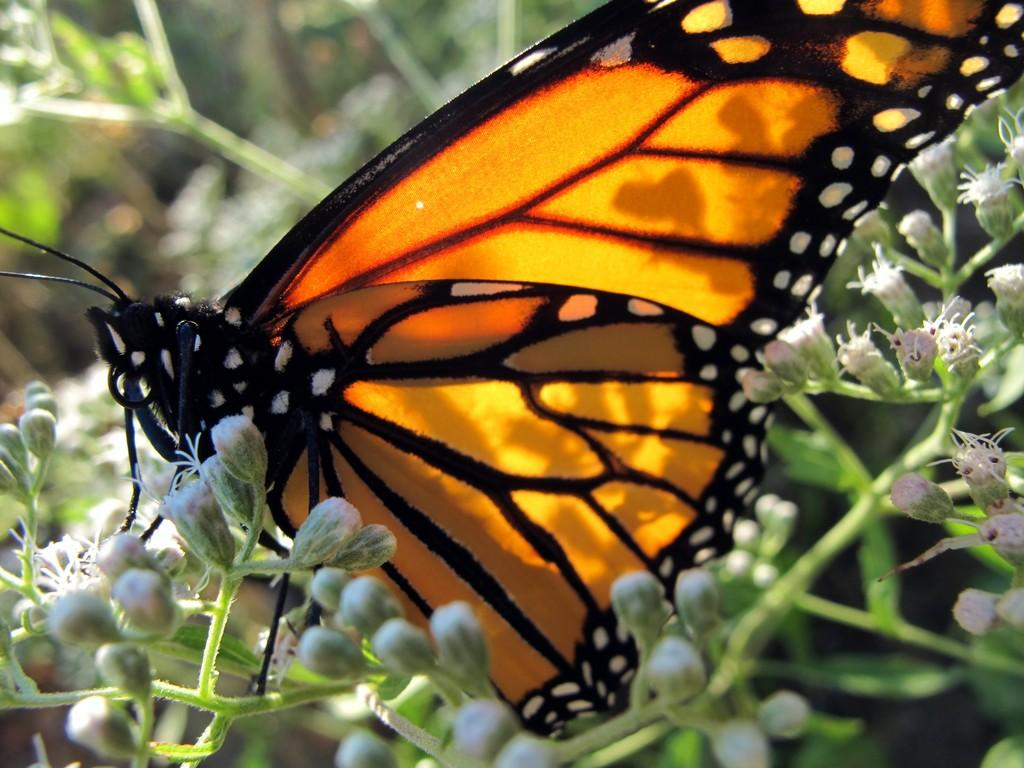What is the main subject of the image? There is a butterfly in the image. Where is the butterfly located in the image? The butterfly is on flowers. Can you describe the background of the image? The background of the image is blurry. How many pots are visible in the image? There are no pots visible in the image. Is the butterfly using its wing to take a selfie in the image? There is no indication in the image that the butterfly is taking a selfie or using its wing for that purpose. 